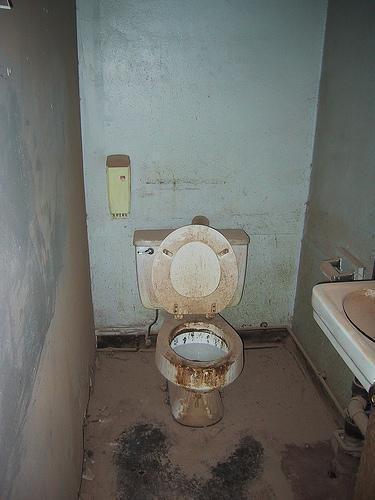How many toilets are in the picture?
Give a very brief answer. 1. 